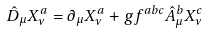<formula> <loc_0><loc_0><loc_500><loc_500>\hat { D } _ { \mu } X _ { \nu } ^ { a } = \partial _ { \mu } X _ { \nu } ^ { a } + g f ^ { a b c } \hat { A } _ { \mu } ^ { b } X _ { \nu } ^ { c }</formula> 